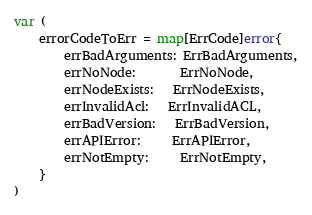<code> <loc_0><loc_0><loc_500><loc_500><_Go_>
var (
	errorCodeToErr = map[ErrCode]error{
		errBadArguments: ErrBadArguments,
		errNoNode:       ErrNoNode,
		errNodeExists:   ErrNodeExists,
		errInvalidAcl:   ErrInvalidACL,
		errBadVersion:   ErrBadVersion,
		errAPIError:     ErrAPIError,
		errNotEmpty:     ErrNotEmpty,
	}
)
</code> 